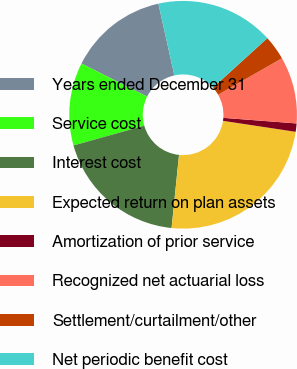<chart> <loc_0><loc_0><loc_500><loc_500><pie_chart><fcel>Years ended December 31<fcel>Service cost<fcel>Interest cost<fcel>Expected return on plan assets<fcel>Amortization of prior service<fcel>Recognized net actuarial loss<fcel>Settlement/curtailment/other<fcel>Net periodic benefit cost<nl><fcel>14.08%<fcel>11.78%<fcel>19.04%<fcel>24.22%<fcel>1.18%<fcel>9.48%<fcel>3.48%<fcel>16.74%<nl></chart> 